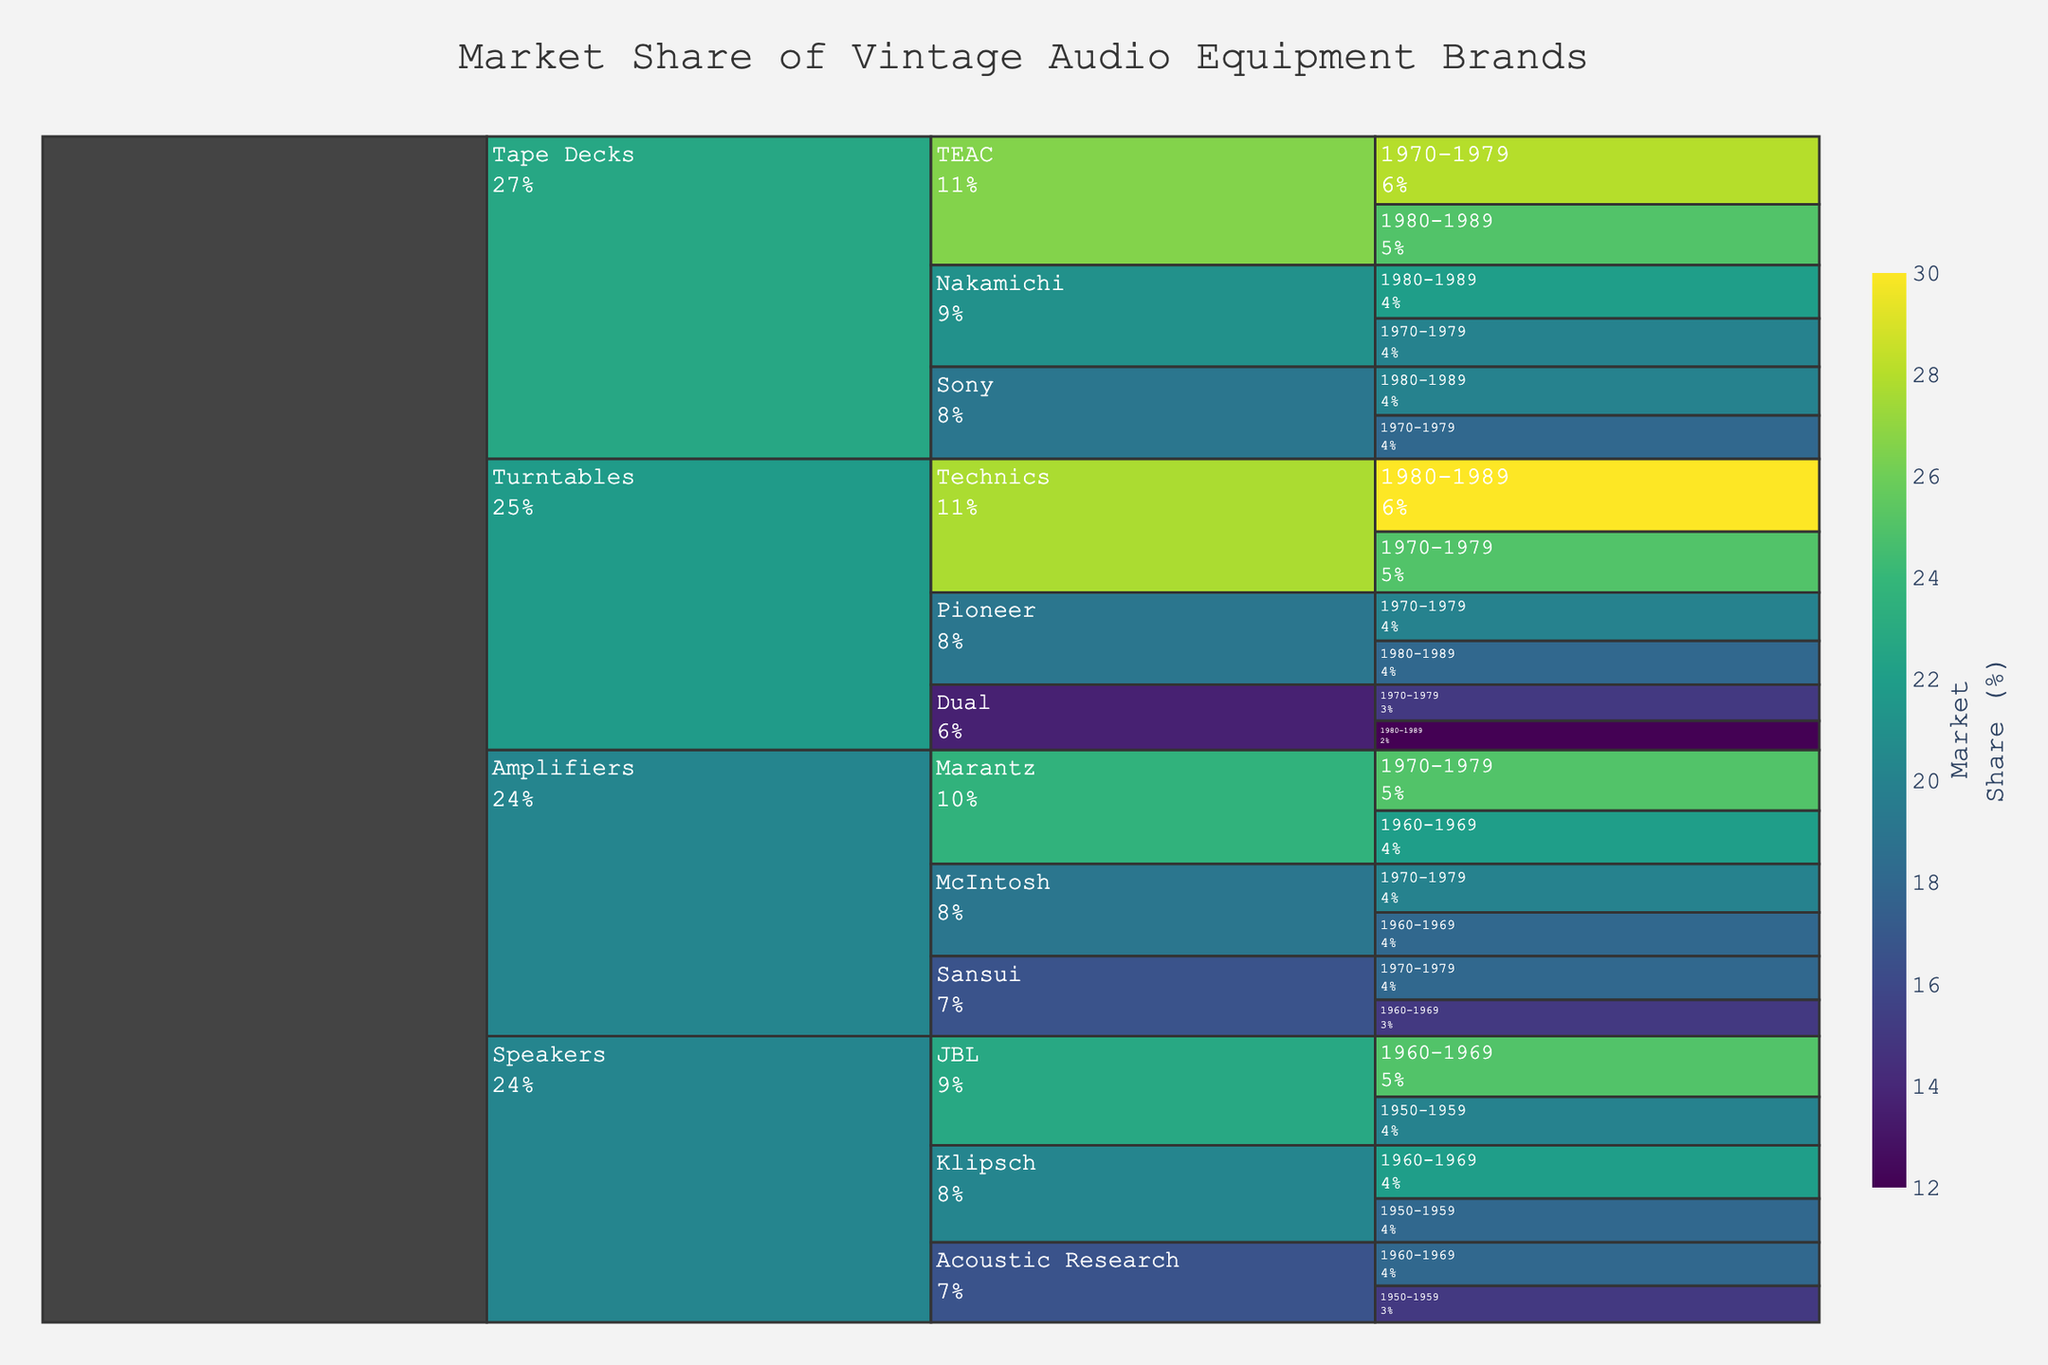What's the market share for Technics turntables during 1970-1979? Look at the Turntables category and find Technics. For the era 1970-1979, the market share is given.
Answer: 25% Which amplifier brand had the highest market share during 1960-1969? Look at the Amplifiers category and check the market share values for the brands in the era 1960-1969. Marantz had the highest value.
Answer: Marantz What is the total market share for tape decks during 1980-1989? Add the market shares of all tape deck brands for the era 1980-1989. TEAC has 25%, Nakamichi has 22%, Sony has 20%. So, 25 + 22 + 20 = 67%.
Answer: 67% How did the market share of JBL speakers change from 1950-1959 to 1960-1969? Find the market share for JBL speakers during both eras and calculate the difference. For 1950-1959, JBL has 20%, and for 1960-1969, JBL has 25%. So, 25 - 20 = 5%.
Answer: Increased by 5% Which product category had the most variety of brands? Count the number of unique brands under each product category. Turntables have 3 brands, Amplifiers have 3 brands, Speakers have 3 brands, and Tape Decks have 3 brands. All categories have the same variety.
Answer: All categories have the same variety What was the market share difference between Dual turntables in 1980-1989 and Pioneer turntables in 1980-1989? Find the market share for Dual turntables and Pioneer turntables in 1980-1989 and calculate the difference. Dual has 12% and Pioneer has 18%. So, 18 - 12 = 6%.
Answer: 6% Which brand had the third highest market share in turntables during the 1970-1979 era? In the Turntables category during 1970-1979, Technics has 25%, Pioneer has 20%, and Dual has 15%. Dual is the third highest.
Answer: Dual How is the color of the market share for McIntosh amplifiers during 1970-1979 indicated on the chart? The chart uses a Viridis color scale, where market share is color-coded. McIntosh amplifiers during 1970-1979 had a market share of 20%, likely towards the middle of the scale.
Answer: Mid-range color on the Viridis scale What percentage of the speaker market did Acoustic Research hold during 1950-1959? Look at the Speakers category for Acoustic Research in the era 1950-1959. The market share is given.
Answer: 15% Which tape deck brand had the second highest average market share across the 1970-1979 and 1980-1989 eras? Calculate the average market share for each tape deck brand across both eras. TEAC: (28 + 25)/2 = 26.5%, Nakamichi: (20 + 22)/2 = 21%, Sony: (18 + 20)/2 = 19%. Nakamichi is the second highest.
Answer: Nakamichi 